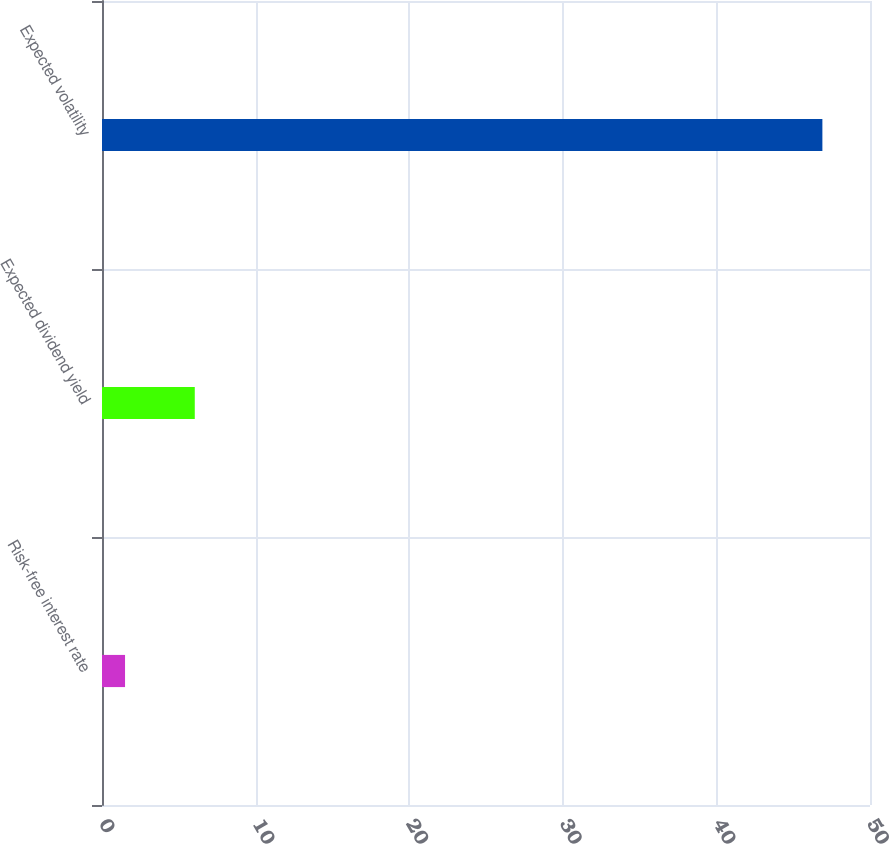Convert chart to OTSL. <chart><loc_0><loc_0><loc_500><loc_500><bar_chart><fcel>Risk-free interest rate<fcel>Expected dividend yield<fcel>Expected volatility<nl><fcel>1.5<fcel>6.04<fcel>46.9<nl></chart> 